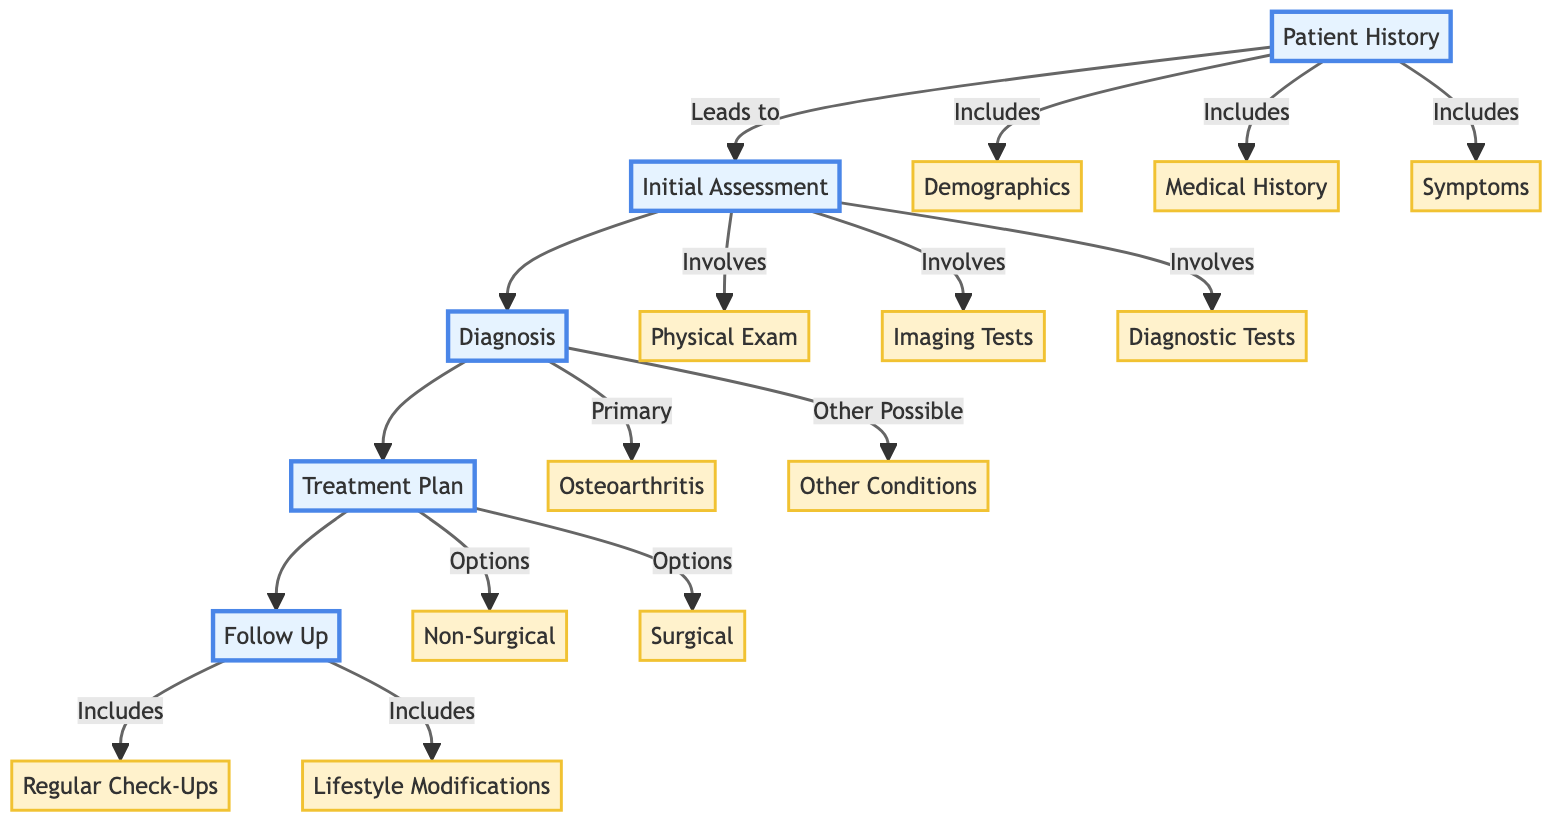What are the three components of Patient History? The diagram lists three components under Patient History: Demographics, Medical History, and Symptoms. These components are directly connected to the Patient History node, showing what information is gathered during this step.
Answer: Demographics, Medical History, Symptoms What is the primary diagnosis made during the evaluation? The diagram specifies that the primary diagnosis is Osteoarthritis, indicated directly under the Diagnosis node. It's the main condition being identified through the clinical path.
Answer: Osteoarthritis How many options are listed in the Treatment Plan? The Treatment Plan contains two main options: Non-Surgical and Surgical. Counted directly from the Treatment Plan node, these represent the two pathways for managing the patient's condition.
Answer: 2 What type of tests are involved in the Initial Assessment? Under the Initial Assessment node, three types of tests are mentioned: Physical Exam, Imaging Tests, and Diagnostic Tests. Each of these falls under the broader category of initial evaluations performed.
Answer: Physical Exam, Imaging Tests, Diagnostic Tests What follow-up action is recommended quarterly? The diagram indicates that quarterly visits with the Orthopedic Specialist are recommended as part of Follow-Up, highlighting the regular check-ups necessary for monitoring the patient's progress.
Answer: Quarterly visits with Orthopedic Specialist What is one possibility listed for other conditions diagnosed? Among the other possible conditions listed in the Diagnosis section, the diagram mentions Meniscus tear as one of the alternatives that can occur alongside or instead of Osteoarthritis.
Answer: Meniscus tear What lifestyle modification is suggested? The Follow-Up section suggests Lifestyle Modifications that include Weight management and Low-impact exercises such as swimming. These are lifestyle changes aimed at improving the patient's overall health and managing joint stress.
Answer: Weight management What is the first step after Patient History? The diagram indicates that Initial Assessment is the immediate next step following Patient History. This represents the flow from gathering patient information to starting the assessment process.
Answer: Initial Assessment 